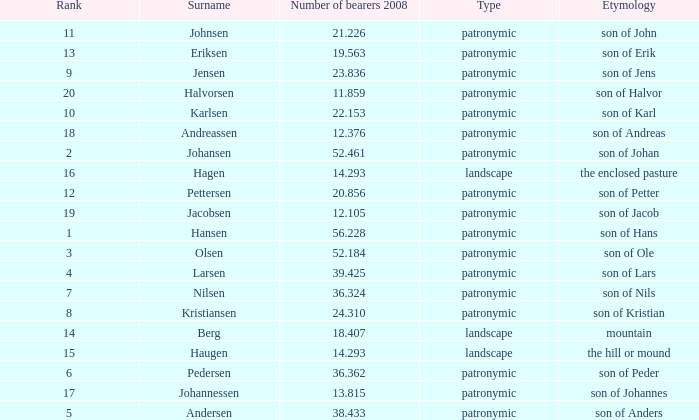What is Type, when Number of Bearers 2008 is greater than 12.376, when Rank is greater than 3, and when Etymology is Son of Jens? Patronymic. 